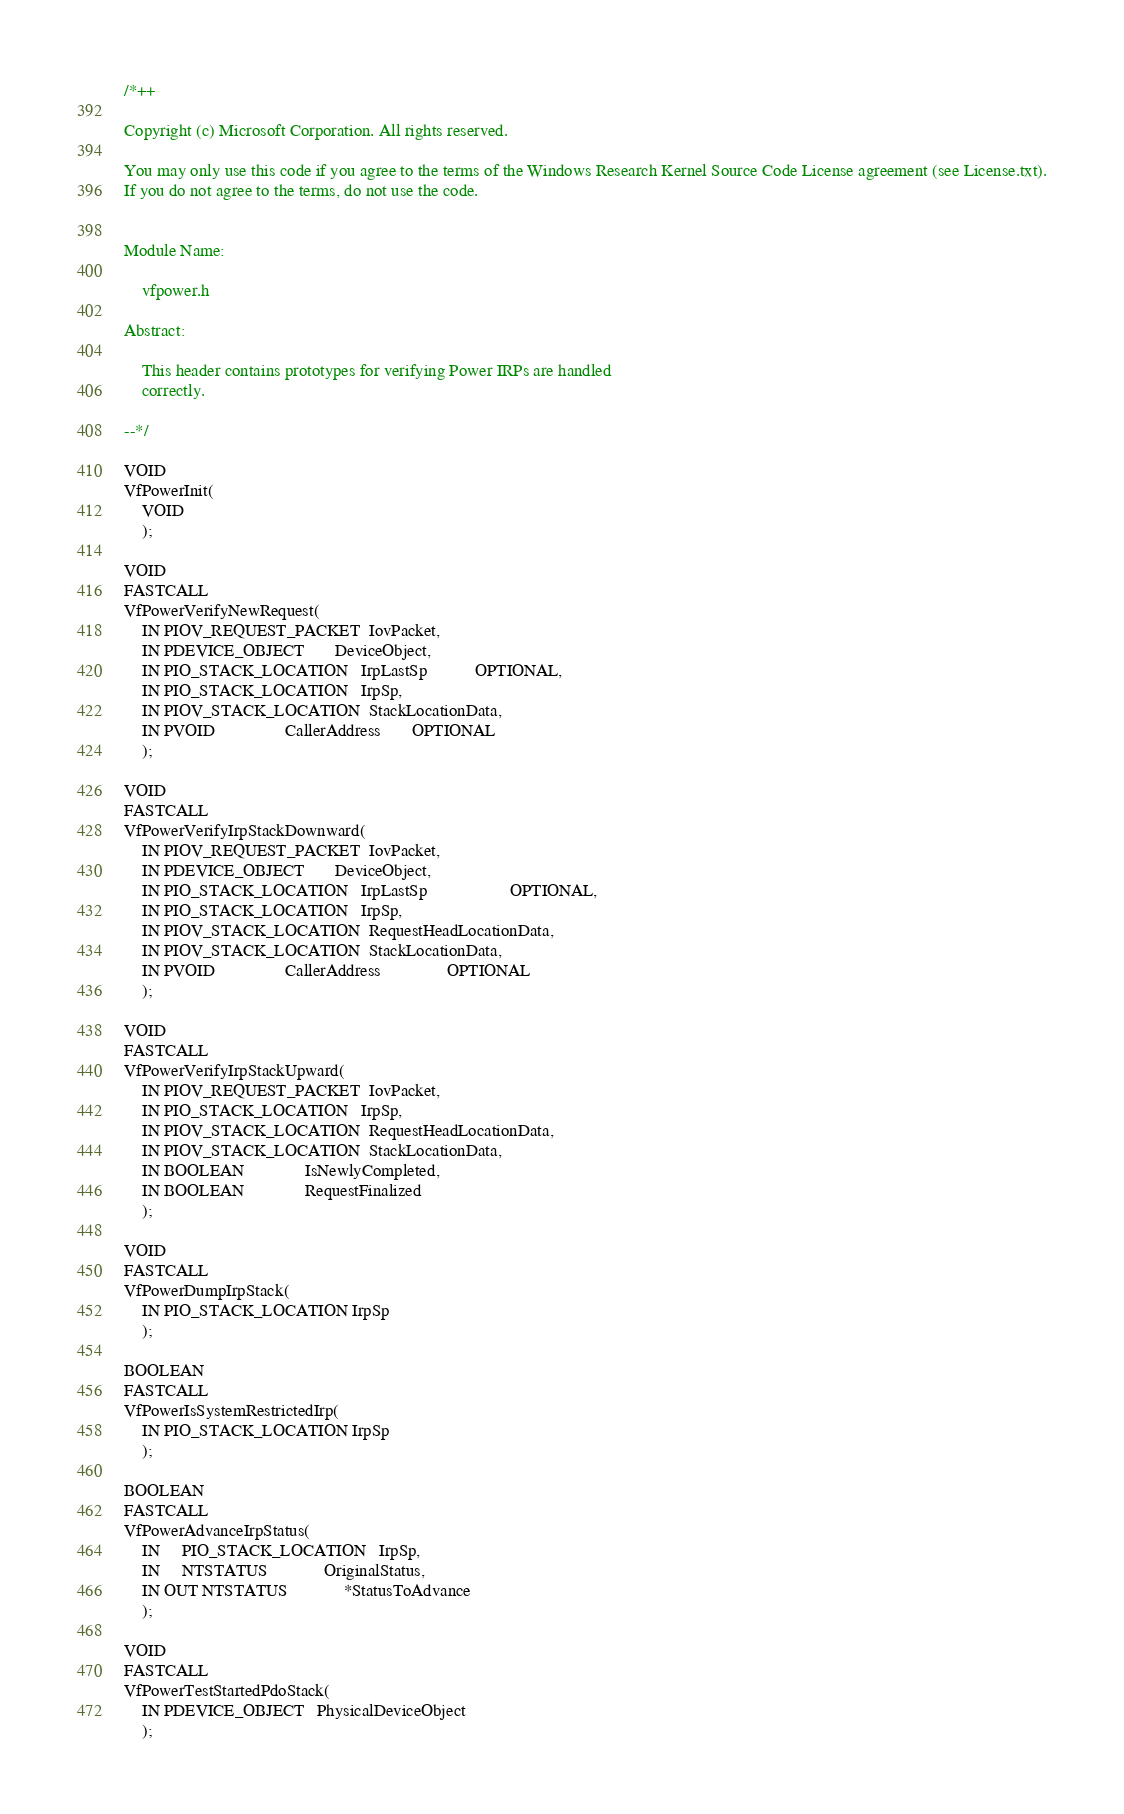<code> <loc_0><loc_0><loc_500><loc_500><_C_>/*++

Copyright (c) Microsoft Corporation. All rights reserved. 

You may only use this code if you agree to the terms of the Windows Research Kernel Source Code License agreement (see License.txt).
If you do not agree to the terms, do not use the code.


Module Name:

    vfpower.h

Abstract:

    This header contains prototypes for verifying Power IRPs are handled
    correctly.

--*/

VOID
VfPowerInit(
    VOID
    );

VOID
FASTCALL
VfPowerVerifyNewRequest(
    IN PIOV_REQUEST_PACKET  IovPacket,
    IN PDEVICE_OBJECT       DeviceObject,
    IN PIO_STACK_LOCATION   IrpLastSp           OPTIONAL,
    IN PIO_STACK_LOCATION   IrpSp,
    IN PIOV_STACK_LOCATION  StackLocationData,
    IN PVOID                CallerAddress       OPTIONAL
    );

VOID
FASTCALL
VfPowerVerifyIrpStackDownward(
    IN PIOV_REQUEST_PACKET  IovPacket,
    IN PDEVICE_OBJECT       DeviceObject,
    IN PIO_STACK_LOCATION   IrpLastSp                   OPTIONAL,
    IN PIO_STACK_LOCATION   IrpSp,
    IN PIOV_STACK_LOCATION  RequestHeadLocationData,
    IN PIOV_STACK_LOCATION  StackLocationData,
    IN PVOID                CallerAddress               OPTIONAL
    );

VOID
FASTCALL
VfPowerVerifyIrpStackUpward(
    IN PIOV_REQUEST_PACKET  IovPacket,
    IN PIO_STACK_LOCATION   IrpSp,
    IN PIOV_STACK_LOCATION  RequestHeadLocationData,
    IN PIOV_STACK_LOCATION  StackLocationData,
    IN BOOLEAN              IsNewlyCompleted,
    IN BOOLEAN              RequestFinalized
    );

VOID
FASTCALL
VfPowerDumpIrpStack(
    IN PIO_STACK_LOCATION IrpSp
    );

BOOLEAN
FASTCALL
VfPowerIsSystemRestrictedIrp(
    IN PIO_STACK_LOCATION IrpSp
    );

BOOLEAN
FASTCALL
VfPowerAdvanceIrpStatus(
    IN     PIO_STACK_LOCATION   IrpSp,
    IN     NTSTATUS             OriginalStatus,
    IN OUT NTSTATUS             *StatusToAdvance
    );

VOID
FASTCALL
VfPowerTestStartedPdoStack(
    IN PDEVICE_OBJECT   PhysicalDeviceObject
    );

</code> 